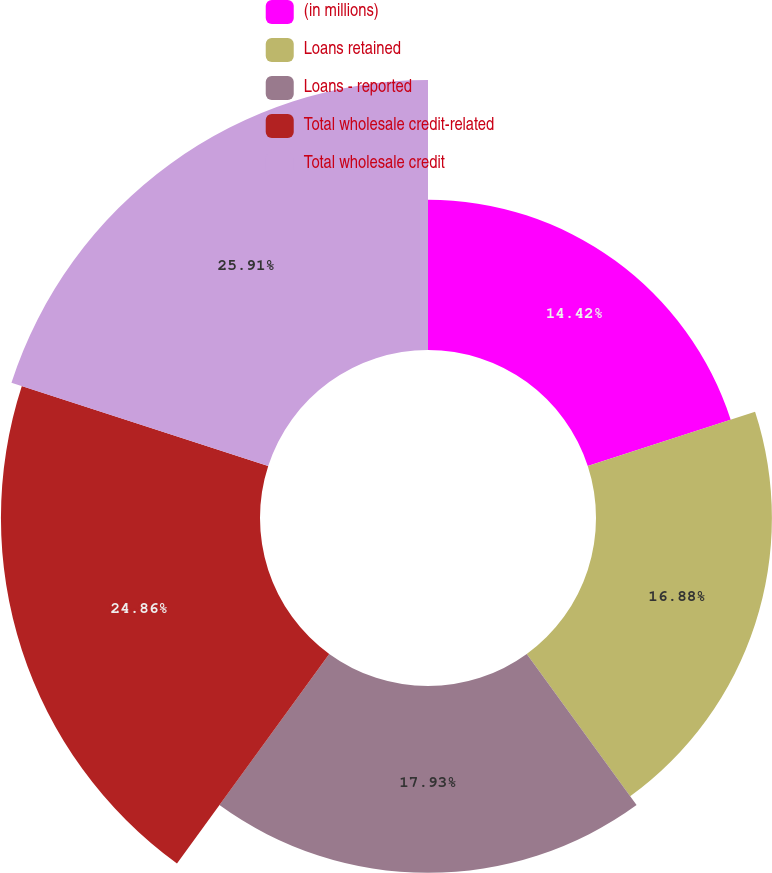Convert chart to OTSL. <chart><loc_0><loc_0><loc_500><loc_500><pie_chart><fcel>(in millions)<fcel>Loans retained<fcel>Loans - reported<fcel>Total wholesale credit-related<fcel>Total wholesale credit<nl><fcel>14.42%<fcel>16.88%<fcel>17.93%<fcel>24.86%<fcel>25.91%<nl></chart> 